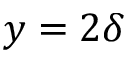<formula> <loc_0><loc_0><loc_500><loc_500>y = 2 \delta</formula> 